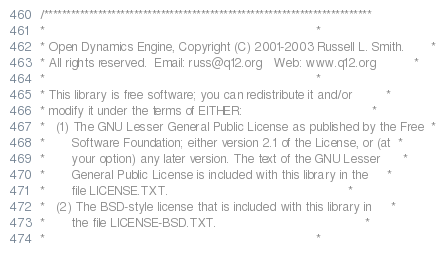Convert code to text. <code><loc_0><loc_0><loc_500><loc_500><_C++_>/*************************************************************************
*                                                                       *
* Open Dynamics Engine, Copyright (C) 2001-2003 Russell L. Smith.       *
* All rights reserved.  Email: russ@q12.org   Web: www.q12.org          *
*                                                                       *
* This library is free software; you can redistribute it and/or         *
* modify it under the terms of EITHER:                                  *
*   (1) The GNU Lesser General Public License as published by the Free  *
*       Software Foundation; either version 2.1 of the License, or (at  *
*       your option) any later version. The text of the GNU Lesser      *
*       General Public License is included with this library in the     *
*       file LICENSE.TXT.                                               *
*   (2) The BSD-style license that is included with this library in     *
*       the file LICENSE-BSD.TXT.                                       *
*                                                                       *</code> 